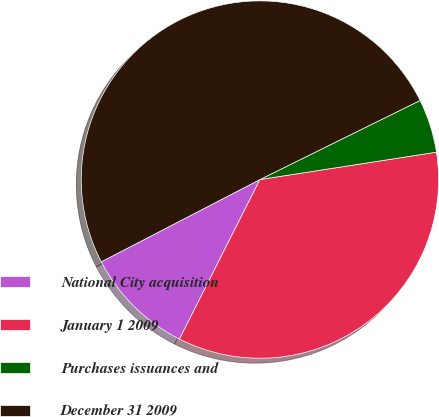Convert chart. <chart><loc_0><loc_0><loc_500><loc_500><pie_chart><fcel>National City acquisition<fcel>January 1 2009<fcel>Purchases issuances and<fcel>December 31 2009<nl><fcel>9.95%<fcel>34.88%<fcel>4.85%<fcel>50.31%<nl></chart> 